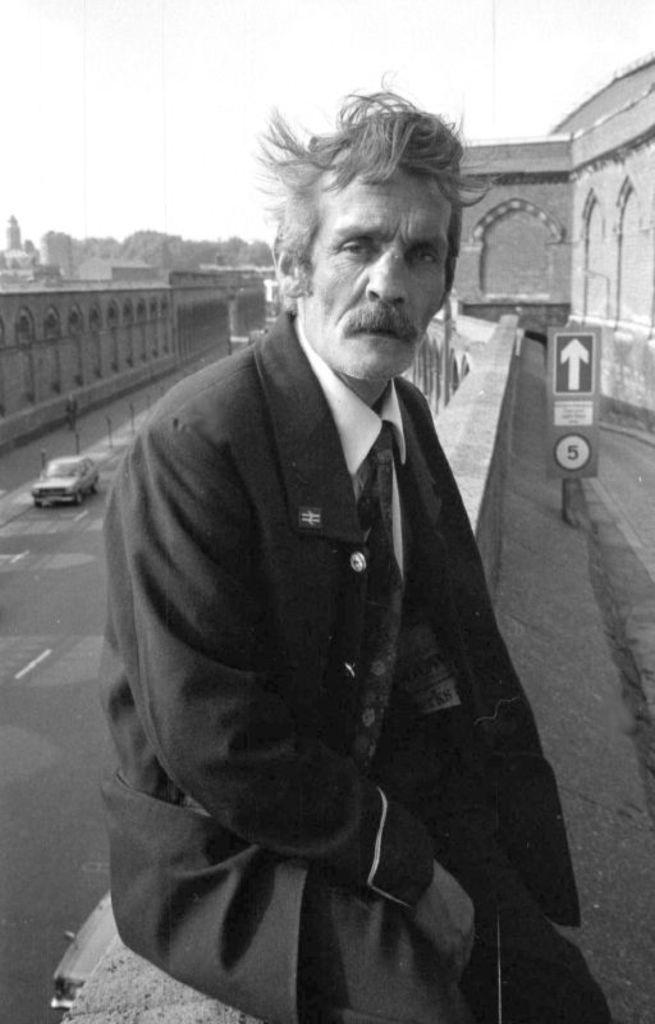What is the man in the image doing? The man is sitting on a wall in the image. What can be seen near the man? There is a signboard in the image. What type of structures are visible in the image? There are buildings in the image. What mode of transportation can be seen on the road? There is a car on the road in the image. What is visible in the background of the image? The sky is visible in the background of the image. What type of hose is being used to water the mine in the image? There is no hose or mine present in the image. What is the man doing with his chin in the image? The man's chin is not doing anything in the image; he is simply sitting on the wall. 